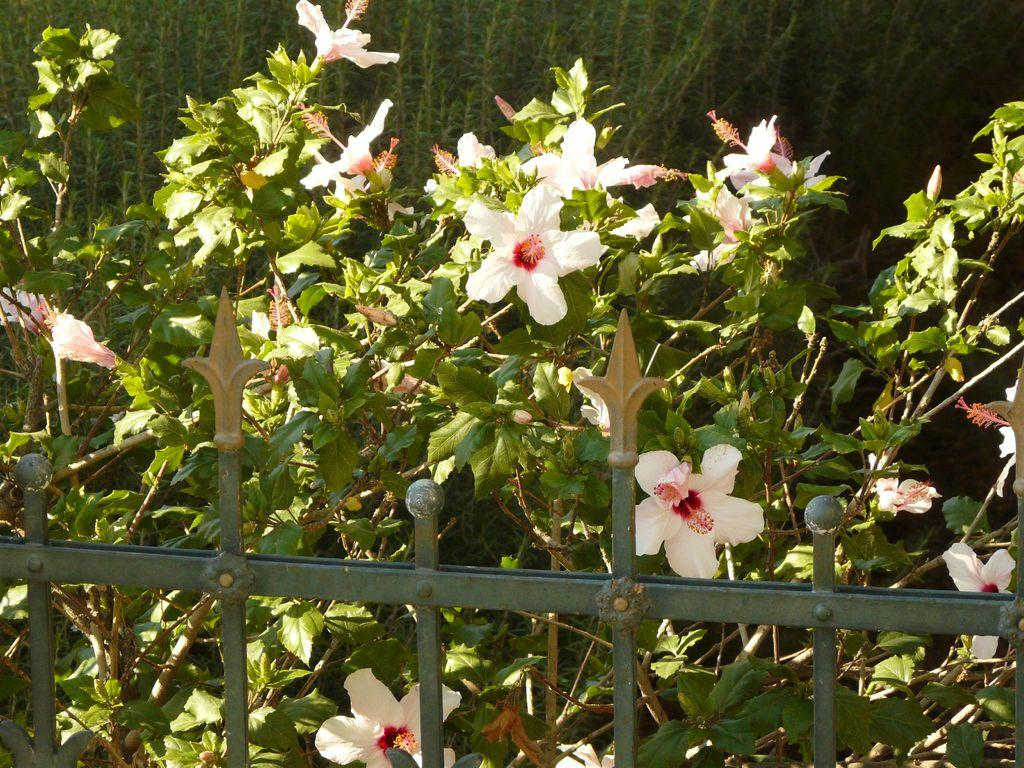What is the main subject in the center of the image? There are plants in the center of the image. What additional feature can be seen with the plants? There are flowers associated with the plants. What is located at the bottom of the image? There is a fence at the bottom of the image. What shape is the frog jumping in the image? There is no frog present in the image, so it is not possible to determine the shape of its jump. 